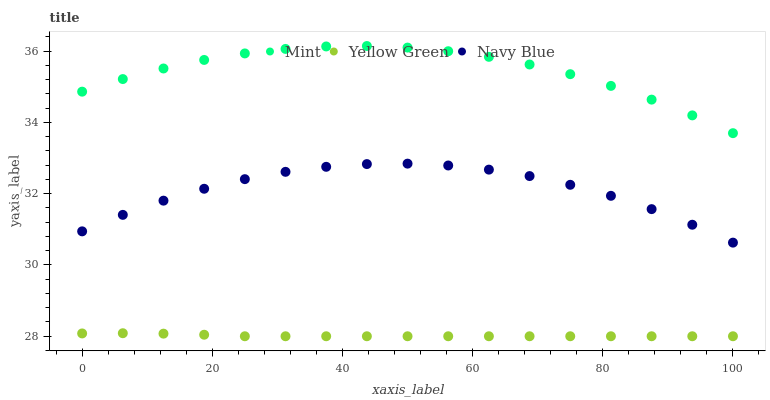Does Yellow Green have the minimum area under the curve?
Answer yes or no. Yes. Does Mint have the maximum area under the curve?
Answer yes or no. Yes. Does Mint have the minimum area under the curve?
Answer yes or no. No. Does Yellow Green have the maximum area under the curve?
Answer yes or no. No. Is Yellow Green the smoothest?
Answer yes or no. Yes. Is Navy Blue the roughest?
Answer yes or no. Yes. Is Mint the smoothest?
Answer yes or no. No. Is Mint the roughest?
Answer yes or no. No. Does Yellow Green have the lowest value?
Answer yes or no. Yes. Does Mint have the lowest value?
Answer yes or no. No. Does Mint have the highest value?
Answer yes or no. Yes. Does Yellow Green have the highest value?
Answer yes or no. No. Is Yellow Green less than Mint?
Answer yes or no. Yes. Is Navy Blue greater than Yellow Green?
Answer yes or no. Yes. Does Yellow Green intersect Mint?
Answer yes or no. No. 